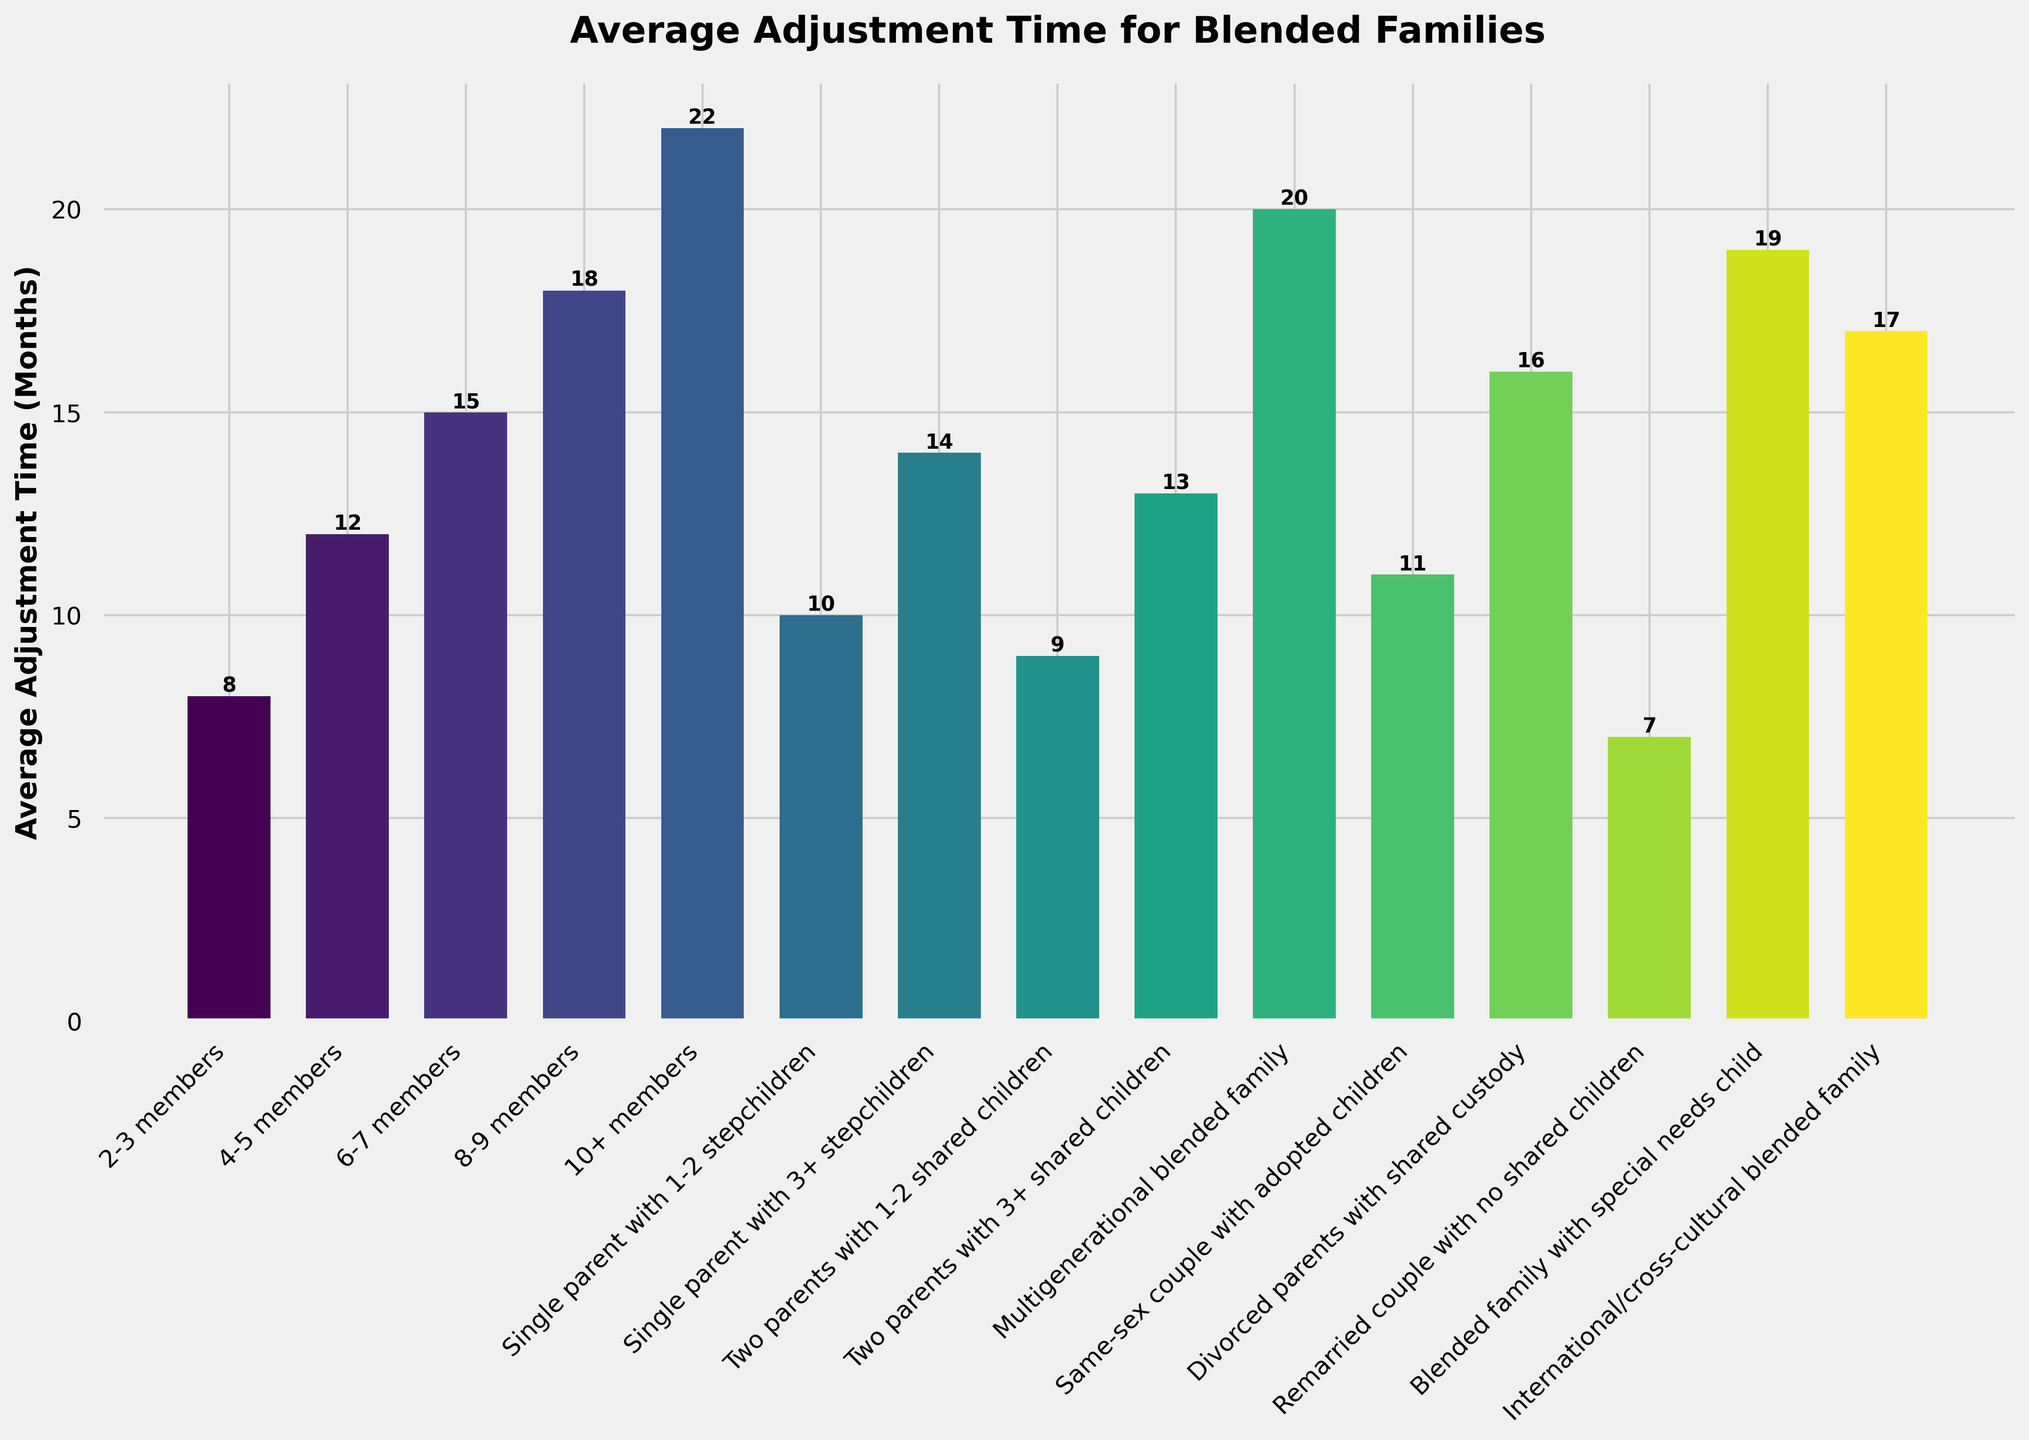Which family size category has the longest average adjustment time? The tallest bar in the figure represents the family size category with the longest average adjustment time. The "10+ members" category has the tallest bar.
Answer: 10+ members How much more time does a blended family with a special needs child take to adjust compared to a remarried couple with no shared children? To find the difference, identify the adjustment times for both categories. The blended family with a special needs child takes 19 months, while a remarried couple with no shared children takes 7 months. Subtract the two values (19 - 7).
Answer: 12 months Which two family size categories have the closest average adjustment times? Examine the heights of the bars to find categories with similar heights. The "Single parent with 1-2 stepchildren" and "Same-sex couple with adopted children" both have similar adjustment times of 10 and 11 months respectively.
Answer: Single parent with 1-2 stepchildren and Same-sex couple with adopted children What is the average adjustment time for all families with more than 6 members? Identify the categories with more than 6 members: "6-7 members", "8-9 members", "10+ members", and "Multigenerational blended family". Calculate the average: (15 + 18 + 22 + 20) / 4.
Answer: 18.75 months Which has a longer average adjustment time: a blended family with a special needs child or an international/cross-cultural blended family? Compare the bars for the two categories. The blended family with a special needs child takes 19 months, while the international/cross-cultural blended family takes 17 months. The special needs child's family has a longer adjustment time.
Answer: Blended family with special needs child What is the combined average adjustment time of single-parent families (both categories)? Identify the adjustment times for "Single parent with 1-2 stepchildren" and "Single parent with 3+ stepchildren". Sum the two values (10 + 14).
Answer: 24 months 